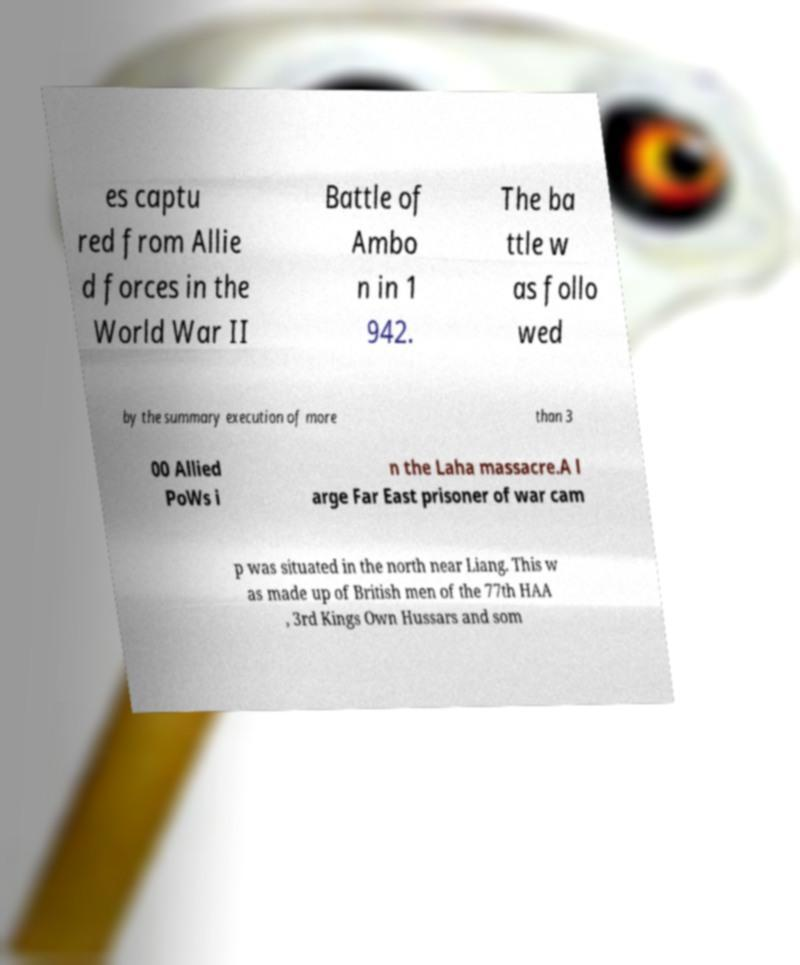There's text embedded in this image that I need extracted. Can you transcribe it verbatim? es captu red from Allie d forces in the World War II Battle of Ambo n in 1 942. The ba ttle w as follo wed by the summary execution of more than 3 00 Allied PoWs i n the Laha massacre.A l arge Far East prisoner of war cam p was situated in the north near Liang. This w as made up of British men of the 77th HAA , 3rd Kings Own Hussars and som 